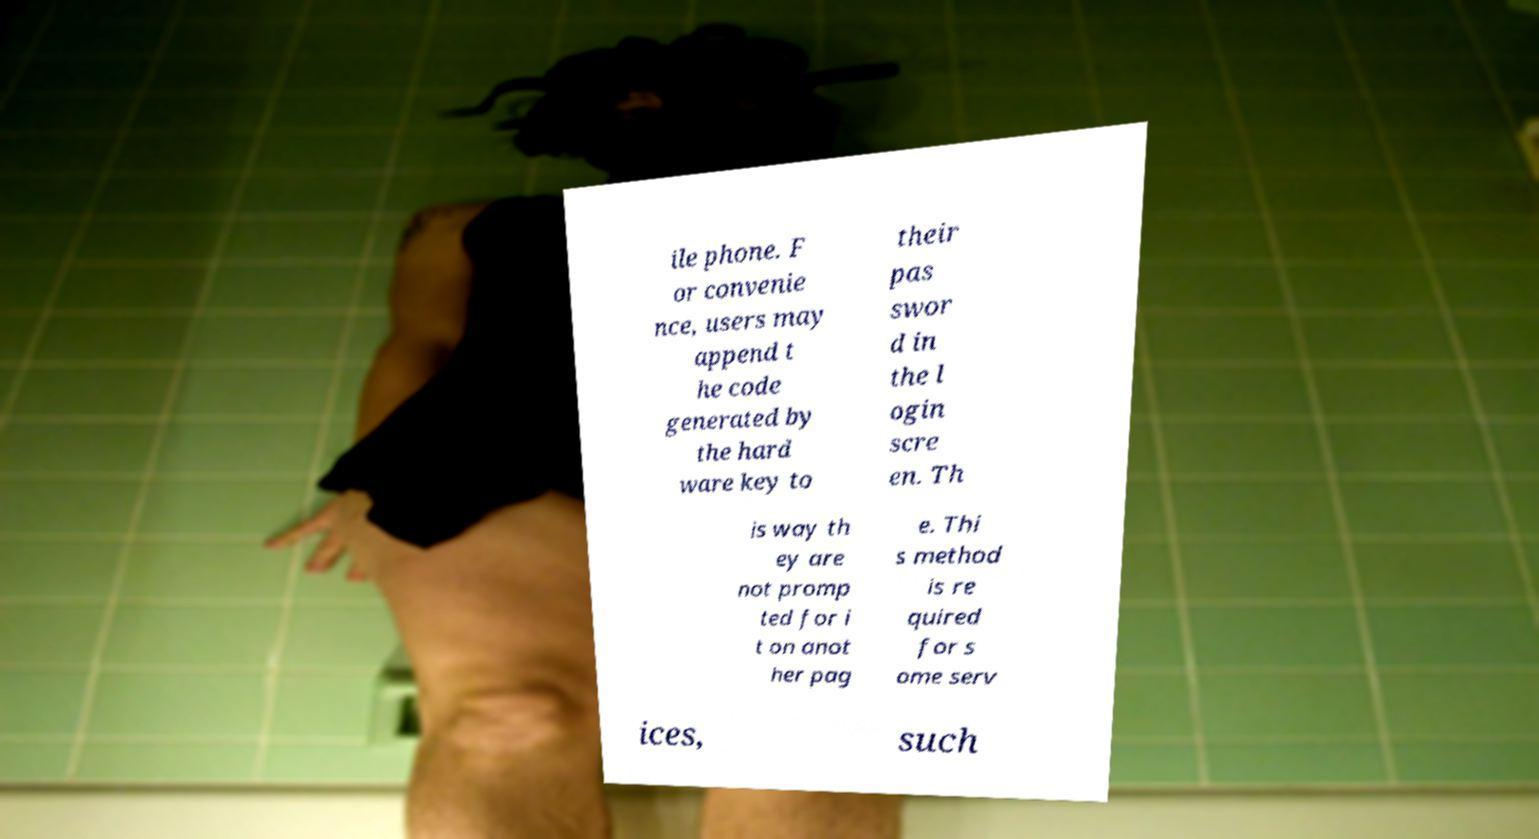Please identify and transcribe the text found in this image. ile phone. F or convenie nce, users may append t he code generated by the hard ware key to their pas swor d in the l ogin scre en. Th is way th ey are not promp ted for i t on anot her pag e. Thi s method is re quired for s ome serv ices, such 